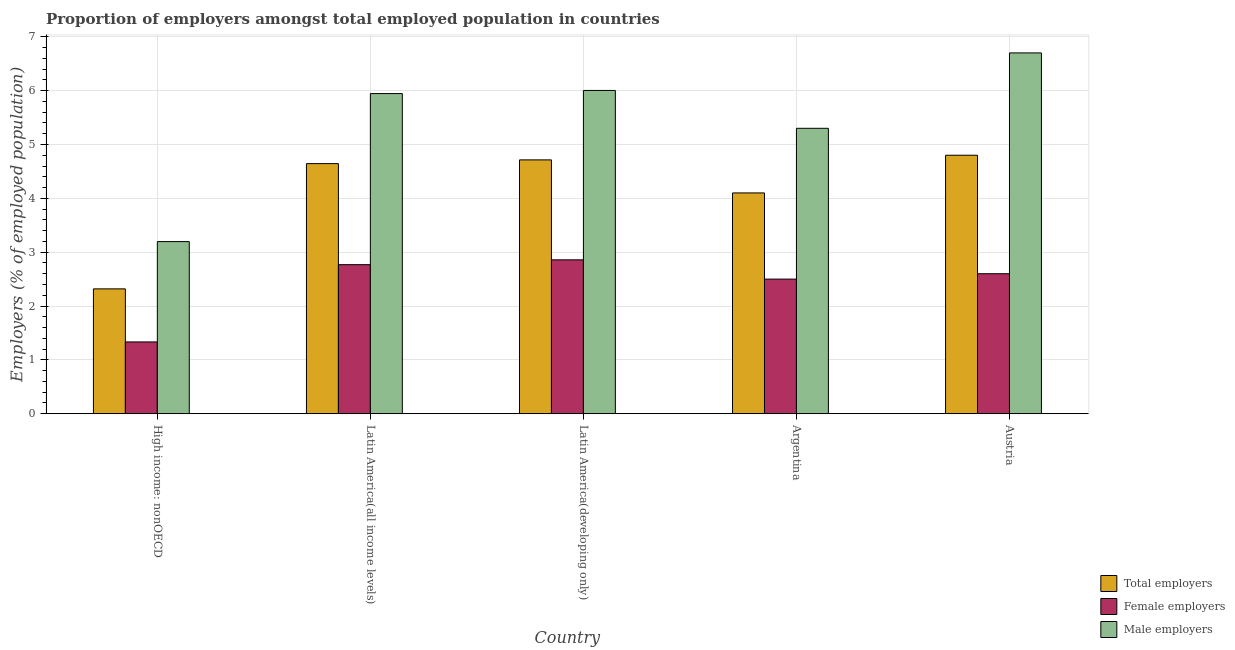How many different coloured bars are there?
Provide a short and direct response. 3. How many groups of bars are there?
Offer a terse response. 5. Are the number of bars per tick equal to the number of legend labels?
Keep it short and to the point. Yes. Are the number of bars on each tick of the X-axis equal?
Provide a succinct answer. Yes. How many bars are there on the 3rd tick from the left?
Offer a very short reply. 3. How many bars are there on the 2nd tick from the right?
Make the answer very short. 3. What is the label of the 1st group of bars from the left?
Make the answer very short. High income: nonOECD. In how many cases, is the number of bars for a given country not equal to the number of legend labels?
Offer a terse response. 0. What is the percentage of female employers in Argentina?
Provide a short and direct response. 2.5. Across all countries, what is the maximum percentage of female employers?
Your answer should be compact. 2.86. Across all countries, what is the minimum percentage of male employers?
Provide a short and direct response. 3.2. In which country was the percentage of male employers maximum?
Make the answer very short. Austria. In which country was the percentage of male employers minimum?
Your response must be concise. High income: nonOECD. What is the total percentage of total employers in the graph?
Give a very brief answer. 20.58. What is the difference between the percentage of total employers in Latin America(all income levels) and that in Latin America(developing only)?
Your response must be concise. -0.07. What is the difference between the percentage of total employers in Argentina and the percentage of female employers in Austria?
Provide a succinct answer. 1.5. What is the average percentage of male employers per country?
Offer a very short reply. 5.43. What is the difference between the percentage of total employers and percentage of female employers in Latin America(all income levels)?
Make the answer very short. 1.88. What is the ratio of the percentage of total employers in Argentina to that in Latin America(developing only)?
Offer a terse response. 0.87. Is the difference between the percentage of total employers in Argentina and Latin America(all income levels) greater than the difference between the percentage of male employers in Argentina and Latin America(all income levels)?
Keep it short and to the point. Yes. What is the difference between the highest and the second highest percentage of male employers?
Your answer should be compact. 0.7. What is the difference between the highest and the lowest percentage of male employers?
Provide a succinct answer. 3.5. In how many countries, is the percentage of female employers greater than the average percentage of female employers taken over all countries?
Ensure brevity in your answer.  4. Is the sum of the percentage of total employers in Austria and Latin America(developing only) greater than the maximum percentage of female employers across all countries?
Your answer should be very brief. Yes. What does the 3rd bar from the left in Austria represents?
Offer a terse response. Male employers. What does the 3rd bar from the right in Argentina represents?
Your answer should be compact. Total employers. Is it the case that in every country, the sum of the percentage of total employers and percentage of female employers is greater than the percentage of male employers?
Provide a short and direct response. Yes. How many bars are there?
Offer a terse response. 15. What is the difference between two consecutive major ticks on the Y-axis?
Your response must be concise. 1. Are the values on the major ticks of Y-axis written in scientific E-notation?
Your response must be concise. No. Does the graph contain any zero values?
Offer a terse response. No. Where does the legend appear in the graph?
Offer a terse response. Bottom right. How many legend labels are there?
Your answer should be very brief. 3. How are the legend labels stacked?
Make the answer very short. Vertical. What is the title of the graph?
Your answer should be compact. Proportion of employers amongst total employed population in countries. What is the label or title of the Y-axis?
Provide a succinct answer. Employers (% of employed population). What is the Employers (% of employed population) of Total employers in High income: nonOECD?
Offer a terse response. 2.32. What is the Employers (% of employed population) of Female employers in High income: nonOECD?
Your answer should be very brief. 1.33. What is the Employers (% of employed population) of Male employers in High income: nonOECD?
Provide a short and direct response. 3.2. What is the Employers (% of employed population) in Total employers in Latin America(all income levels)?
Your answer should be compact. 4.64. What is the Employers (% of employed population) in Female employers in Latin America(all income levels)?
Offer a terse response. 2.77. What is the Employers (% of employed population) in Male employers in Latin America(all income levels)?
Your answer should be very brief. 5.95. What is the Employers (% of employed population) in Total employers in Latin America(developing only)?
Keep it short and to the point. 4.71. What is the Employers (% of employed population) in Female employers in Latin America(developing only)?
Give a very brief answer. 2.86. What is the Employers (% of employed population) of Male employers in Latin America(developing only)?
Make the answer very short. 6. What is the Employers (% of employed population) of Total employers in Argentina?
Provide a succinct answer. 4.1. What is the Employers (% of employed population) of Male employers in Argentina?
Provide a succinct answer. 5.3. What is the Employers (% of employed population) in Total employers in Austria?
Give a very brief answer. 4.8. What is the Employers (% of employed population) of Female employers in Austria?
Ensure brevity in your answer.  2.6. What is the Employers (% of employed population) in Male employers in Austria?
Offer a terse response. 6.7. Across all countries, what is the maximum Employers (% of employed population) in Total employers?
Your answer should be very brief. 4.8. Across all countries, what is the maximum Employers (% of employed population) in Female employers?
Ensure brevity in your answer.  2.86. Across all countries, what is the maximum Employers (% of employed population) in Male employers?
Your response must be concise. 6.7. Across all countries, what is the minimum Employers (% of employed population) of Total employers?
Your answer should be compact. 2.32. Across all countries, what is the minimum Employers (% of employed population) of Female employers?
Provide a short and direct response. 1.33. Across all countries, what is the minimum Employers (% of employed population) in Male employers?
Provide a short and direct response. 3.2. What is the total Employers (% of employed population) in Total employers in the graph?
Offer a terse response. 20.58. What is the total Employers (% of employed population) of Female employers in the graph?
Your response must be concise. 12.06. What is the total Employers (% of employed population) in Male employers in the graph?
Give a very brief answer. 27.14. What is the difference between the Employers (% of employed population) of Total employers in High income: nonOECD and that in Latin America(all income levels)?
Provide a succinct answer. -2.33. What is the difference between the Employers (% of employed population) in Female employers in High income: nonOECD and that in Latin America(all income levels)?
Ensure brevity in your answer.  -1.43. What is the difference between the Employers (% of employed population) of Male employers in High income: nonOECD and that in Latin America(all income levels)?
Ensure brevity in your answer.  -2.75. What is the difference between the Employers (% of employed population) in Total employers in High income: nonOECD and that in Latin America(developing only)?
Your answer should be very brief. -2.39. What is the difference between the Employers (% of employed population) in Female employers in High income: nonOECD and that in Latin America(developing only)?
Your response must be concise. -1.52. What is the difference between the Employers (% of employed population) of Male employers in High income: nonOECD and that in Latin America(developing only)?
Give a very brief answer. -2.81. What is the difference between the Employers (% of employed population) of Total employers in High income: nonOECD and that in Argentina?
Ensure brevity in your answer.  -1.78. What is the difference between the Employers (% of employed population) of Female employers in High income: nonOECD and that in Argentina?
Your answer should be compact. -1.17. What is the difference between the Employers (% of employed population) in Male employers in High income: nonOECD and that in Argentina?
Provide a succinct answer. -2.1. What is the difference between the Employers (% of employed population) of Total employers in High income: nonOECD and that in Austria?
Make the answer very short. -2.48. What is the difference between the Employers (% of employed population) of Female employers in High income: nonOECD and that in Austria?
Provide a short and direct response. -1.27. What is the difference between the Employers (% of employed population) in Male employers in High income: nonOECD and that in Austria?
Provide a short and direct response. -3.5. What is the difference between the Employers (% of employed population) in Total employers in Latin America(all income levels) and that in Latin America(developing only)?
Ensure brevity in your answer.  -0.07. What is the difference between the Employers (% of employed population) in Female employers in Latin America(all income levels) and that in Latin America(developing only)?
Provide a short and direct response. -0.09. What is the difference between the Employers (% of employed population) of Male employers in Latin America(all income levels) and that in Latin America(developing only)?
Give a very brief answer. -0.06. What is the difference between the Employers (% of employed population) in Total employers in Latin America(all income levels) and that in Argentina?
Keep it short and to the point. 0.54. What is the difference between the Employers (% of employed population) of Female employers in Latin America(all income levels) and that in Argentina?
Your answer should be very brief. 0.27. What is the difference between the Employers (% of employed population) in Male employers in Latin America(all income levels) and that in Argentina?
Offer a very short reply. 0.65. What is the difference between the Employers (% of employed population) in Total employers in Latin America(all income levels) and that in Austria?
Your answer should be compact. -0.16. What is the difference between the Employers (% of employed population) in Female employers in Latin America(all income levels) and that in Austria?
Keep it short and to the point. 0.17. What is the difference between the Employers (% of employed population) in Male employers in Latin America(all income levels) and that in Austria?
Keep it short and to the point. -0.75. What is the difference between the Employers (% of employed population) in Total employers in Latin America(developing only) and that in Argentina?
Ensure brevity in your answer.  0.61. What is the difference between the Employers (% of employed population) of Female employers in Latin America(developing only) and that in Argentina?
Your answer should be compact. 0.36. What is the difference between the Employers (% of employed population) in Male employers in Latin America(developing only) and that in Argentina?
Your response must be concise. 0.7. What is the difference between the Employers (% of employed population) in Total employers in Latin America(developing only) and that in Austria?
Your response must be concise. -0.09. What is the difference between the Employers (% of employed population) of Female employers in Latin America(developing only) and that in Austria?
Your answer should be very brief. 0.26. What is the difference between the Employers (% of employed population) in Male employers in Latin America(developing only) and that in Austria?
Provide a succinct answer. -0.7. What is the difference between the Employers (% of employed population) of Total employers in Argentina and that in Austria?
Your answer should be very brief. -0.7. What is the difference between the Employers (% of employed population) of Male employers in Argentina and that in Austria?
Your answer should be very brief. -1.4. What is the difference between the Employers (% of employed population) in Total employers in High income: nonOECD and the Employers (% of employed population) in Female employers in Latin America(all income levels)?
Ensure brevity in your answer.  -0.45. What is the difference between the Employers (% of employed population) of Total employers in High income: nonOECD and the Employers (% of employed population) of Male employers in Latin America(all income levels)?
Ensure brevity in your answer.  -3.63. What is the difference between the Employers (% of employed population) in Female employers in High income: nonOECD and the Employers (% of employed population) in Male employers in Latin America(all income levels)?
Provide a short and direct response. -4.61. What is the difference between the Employers (% of employed population) in Total employers in High income: nonOECD and the Employers (% of employed population) in Female employers in Latin America(developing only)?
Provide a succinct answer. -0.54. What is the difference between the Employers (% of employed population) in Total employers in High income: nonOECD and the Employers (% of employed population) in Male employers in Latin America(developing only)?
Your response must be concise. -3.68. What is the difference between the Employers (% of employed population) in Female employers in High income: nonOECD and the Employers (% of employed population) in Male employers in Latin America(developing only)?
Ensure brevity in your answer.  -4.67. What is the difference between the Employers (% of employed population) in Total employers in High income: nonOECD and the Employers (% of employed population) in Female employers in Argentina?
Keep it short and to the point. -0.18. What is the difference between the Employers (% of employed population) in Total employers in High income: nonOECD and the Employers (% of employed population) in Male employers in Argentina?
Offer a terse response. -2.98. What is the difference between the Employers (% of employed population) of Female employers in High income: nonOECD and the Employers (% of employed population) of Male employers in Argentina?
Your response must be concise. -3.97. What is the difference between the Employers (% of employed population) in Total employers in High income: nonOECD and the Employers (% of employed population) in Female employers in Austria?
Ensure brevity in your answer.  -0.28. What is the difference between the Employers (% of employed population) of Total employers in High income: nonOECD and the Employers (% of employed population) of Male employers in Austria?
Make the answer very short. -4.38. What is the difference between the Employers (% of employed population) in Female employers in High income: nonOECD and the Employers (% of employed population) in Male employers in Austria?
Offer a very short reply. -5.37. What is the difference between the Employers (% of employed population) in Total employers in Latin America(all income levels) and the Employers (% of employed population) in Female employers in Latin America(developing only)?
Provide a succinct answer. 1.79. What is the difference between the Employers (% of employed population) in Total employers in Latin America(all income levels) and the Employers (% of employed population) in Male employers in Latin America(developing only)?
Ensure brevity in your answer.  -1.36. What is the difference between the Employers (% of employed population) in Female employers in Latin America(all income levels) and the Employers (% of employed population) in Male employers in Latin America(developing only)?
Make the answer very short. -3.23. What is the difference between the Employers (% of employed population) in Total employers in Latin America(all income levels) and the Employers (% of employed population) in Female employers in Argentina?
Keep it short and to the point. 2.14. What is the difference between the Employers (% of employed population) in Total employers in Latin America(all income levels) and the Employers (% of employed population) in Male employers in Argentina?
Ensure brevity in your answer.  -0.66. What is the difference between the Employers (% of employed population) of Female employers in Latin America(all income levels) and the Employers (% of employed population) of Male employers in Argentina?
Give a very brief answer. -2.53. What is the difference between the Employers (% of employed population) of Total employers in Latin America(all income levels) and the Employers (% of employed population) of Female employers in Austria?
Provide a succinct answer. 2.04. What is the difference between the Employers (% of employed population) in Total employers in Latin America(all income levels) and the Employers (% of employed population) in Male employers in Austria?
Your answer should be compact. -2.06. What is the difference between the Employers (% of employed population) in Female employers in Latin America(all income levels) and the Employers (% of employed population) in Male employers in Austria?
Provide a succinct answer. -3.93. What is the difference between the Employers (% of employed population) of Total employers in Latin America(developing only) and the Employers (% of employed population) of Female employers in Argentina?
Your answer should be compact. 2.21. What is the difference between the Employers (% of employed population) of Total employers in Latin America(developing only) and the Employers (% of employed population) of Male employers in Argentina?
Ensure brevity in your answer.  -0.59. What is the difference between the Employers (% of employed population) in Female employers in Latin America(developing only) and the Employers (% of employed population) in Male employers in Argentina?
Keep it short and to the point. -2.44. What is the difference between the Employers (% of employed population) in Total employers in Latin America(developing only) and the Employers (% of employed population) in Female employers in Austria?
Offer a terse response. 2.11. What is the difference between the Employers (% of employed population) in Total employers in Latin America(developing only) and the Employers (% of employed population) in Male employers in Austria?
Provide a succinct answer. -1.99. What is the difference between the Employers (% of employed population) in Female employers in Latin America(developing only) and the Employers (% of employed population) in Male employers in Austria?
Provide a succinct answer. -3.84. What is the difference between the Employers (% of employed population) of Total employers in Argentina and the Employers (% of employed population) of Male employers in Austria?
Keep it short and to the point. -2.6. What is the difference between the Employers (% of employed population) in Female employers in Argentina and the Employers (% of employed population) in Male employers in Austria?
Give a very brief answer. -4.2. What is the average Employers (% of employed population) in Total employers per country?
Offer a very short reply. 4.12. What is the average Employers (% of employed population) of Female employers per country?
Keep it short and to the point. 2.41. What is the average Employers (% of employed population) of Male employers per country?
Provide a succinct answer. 5.43. What is the difference between the Employers (% of employed population) in Total employers and Employers (% of employed population) in Female employers in High income: nonOECD?
Give a very brief answer. 0.99. What is the difference between the Employers (% of employed population) in Total employers and Employers (% of employed population) in Male employers in High income: nonOECD?
Provide a short and direct response. -0.88. What is the difference between the Employers (% of employed population) in Female employers and Employers (% of employed population) in Male employers in High income: nonOECD?
Ensure brevity in your answer.  -1.86. What is the difference between the Employers (% of employed population) in Total employers and Employers (% of employed population) in Female employers in Latin America(all income levels)?
Offer a terse response. 1.88. What is the difference between the Employers (% of employed population) of Total employers and Employers (% of employed population) of Male employers in Latin America(all income levels)?
Offer a very short reply. -1.3. What is the difference between the Employers (% of employed population) of Female employers and Employers (% of employed population) of Male employers in Latin America(all income levels)?
Provide a short and direct response. -3.18. What is the difference between the Employers (% of employed population) of Total employers and Employers (% of employed population) of Female employers in Latin America(developing only)?
Provide a succinct answer. 1.86. What is the difference between the Employers (% of employed population) in Total employers and Employers (% of employed population) in Male employers in Latin America(developing only)?
Your response must be concise. -1.29. What is the difference between the Employers (% of employed population) in Female employers and Employers (% of employed population) in Male employers in Latin America(developing only)?
Your answer should be compact. -3.15. What is the difference between the Employers (% of employed population) in Total employers and Employers (% of employed population) in Male employers in Argentina?
Offer a very short reply. -1.2. What is the ratio of the Employers (% of employed population) of Total employers in High income: nonOECD to that in Latin America(all income levels)?
Your response must be concise. 0.5. What is the ratio of the Employers (% of employed population) in Female employers in High income: nonOECD to that in Latin America(all income levels)?
Ensure brevity in your answer.  0.48. What is the ratio of the Employers (% of employed population) of Male employers in High income: nonOECD to that in Latin America(all income levels)?
Give a very brief answer. 0.54. What is the ratio of the Employers (% of employed population) of Total employers in High income: nonOECD to that in Latin America(developing only)?
Offer a very short reply. 0.49. What is the ratio of the Employers (% of employed population) in Female employers in High income: nonOECD to that in Latin America(developing only)?
Your answer should be very brief. 0.47. What is the ratio of the Employers (% of employed population) in Male employers in High income: nonOECD to that in Latin America(developing only)?
Offer a very short reply. 0.53. What is the ratio of the Employers (% of employed population) in Total employers in High income: nonOECD to that in Argentina?
Provide a short and direct response. 0.57. What is the ratio of the Employers (% of employed population) of Female employers in High income: nonOECD to that in Argentina?
Your answer should be very brief. 0.53. What is the ratio of the Employers (% of employed population) of Male employers in High income: nonOECD to that in Argentina?
Give a very brief answer. 0.6. What is the ratio of the Employers (% of employed population) in Total employers in High income: nonOECD to that in Austria?
Your answer should be compact. 0.48. What is the ratio of the Employers (% of employed population) in Female employers in High income: nonOECD to that in Austria?
Make the answer very short. 0.51. What is the ratio of the Employers (% of employed population) of Male employers in High income: nonOECD to that in Austria?
Your answer should be compact. 0.48. What is the ratio of the Employers (% of employed population) of Total employers in Latin America(all income levels) to that in Latin America(developing only)?
Offer a terse response. 0.99. What is the ratio of the Employers (% of employed population) of Female employers in Latin America(all income levels) to that in Latin America(developing only)?
Give a very brief answer. 0.97. What is the ratio of the Employers (% of employed population) of Total employers in Latin America(all income levels) to that in Argentina?
Your answer should be very brief. 1.13. What is the ratio of the Employers (% of employed population) of Female employers in Latin America(all income levels) to that in Argentina?
Provide a succinct answer. 1.11. What is the ratio of the Employers (% of employed population) in Male employers in Latin America(all income levels) to that in Argentina?
Provide a succinct answer. 1.12. What is the ratio of the Employers (% of employed population) in Total employers in Latin America(all income levels) to that in Austria?
Ensure brevity in your answer.  0.97. What is the ratio of the Employers (% of employed population) in Female employers in Latin America(all income levels) to that in Austria?
Offer a very short reply. 1.06. What is the ratio of the Employers (% of employed population) in Male employers in Latin America(all income levels) to that in Austria?
Your response must be concise. 0.89. What is the ratio of the Employers (% of employed population) of Total employers in Latin America(developing only) to that in Argentina?
Ensure brevity in your answer.  1.15. What is the ratio of the Employers (% of employed population) in Female employers in Latin America(developing only) to that in Argentina?
Your response must be concise. 1.14. What is the ratio of the Employers (% of employed population) in Male employers in Latin America(developing only) to that in Argentina?
Your answer should be compact. 1.13. What is the ratio of the Employers (% of employed population) of Total employers in Latin America(developing only) to that in Austria?
Provide a short and direct response. 0.98. What is the ratio of the Employers (% of employed population) in Female employers in Latin America(developing only) to that in Austria?
Offer a very short reply. 1.1. What is the ratio of the Employers (% of employed population) of Male employers in Latin America(developing only) to that in Austria?
Provide a succinct answer. 0.9. What is the ratio of the Employers (% of employed population) of Total employers in Argentina to that in Austria?
Offer a terse response. 0.85. What is the ratio of the Employers (% of employed population) of Female employers in Argentina to that in Austria?
Your answer should be very brief. 0.96. What is the ratio of the Employers (% of employed population) of Male employers in Argentina to that in Austria?
Make the answer very short. 0.79. What is the difference between the highest and the second highest Employers (% of employed population) of Total employers?
Your answer should be very brief. 0.09. What is the difference between the highest and the second highest Employers (% of employed population) of Female employers?
Your answer should be very brief. 0.09. What is the difference between the highest and the second highest Employers (% of employed population) in Male employers?
Your answer should be very brief. 0.7. What is the difference between the highest and the lowest Employers (% of employed population) of Total employers?
Give a very brief answer. 2.48. What is the difference between the highest and the lowest Employers (% of employed population) in Female employers?
Your answer should be very brief. 1.52. What is the difference between the highest and the lowest Employers (% of employed population) of Male employers?
Provide a short and direct response. 3.5. 